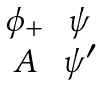<formula> <loc_0><loc_0><loc_500><loc_500>\begin{matrix} \phi _ { + } & \psi \\ A & \psi ^ { \prime } \end{matrix}</formula> 